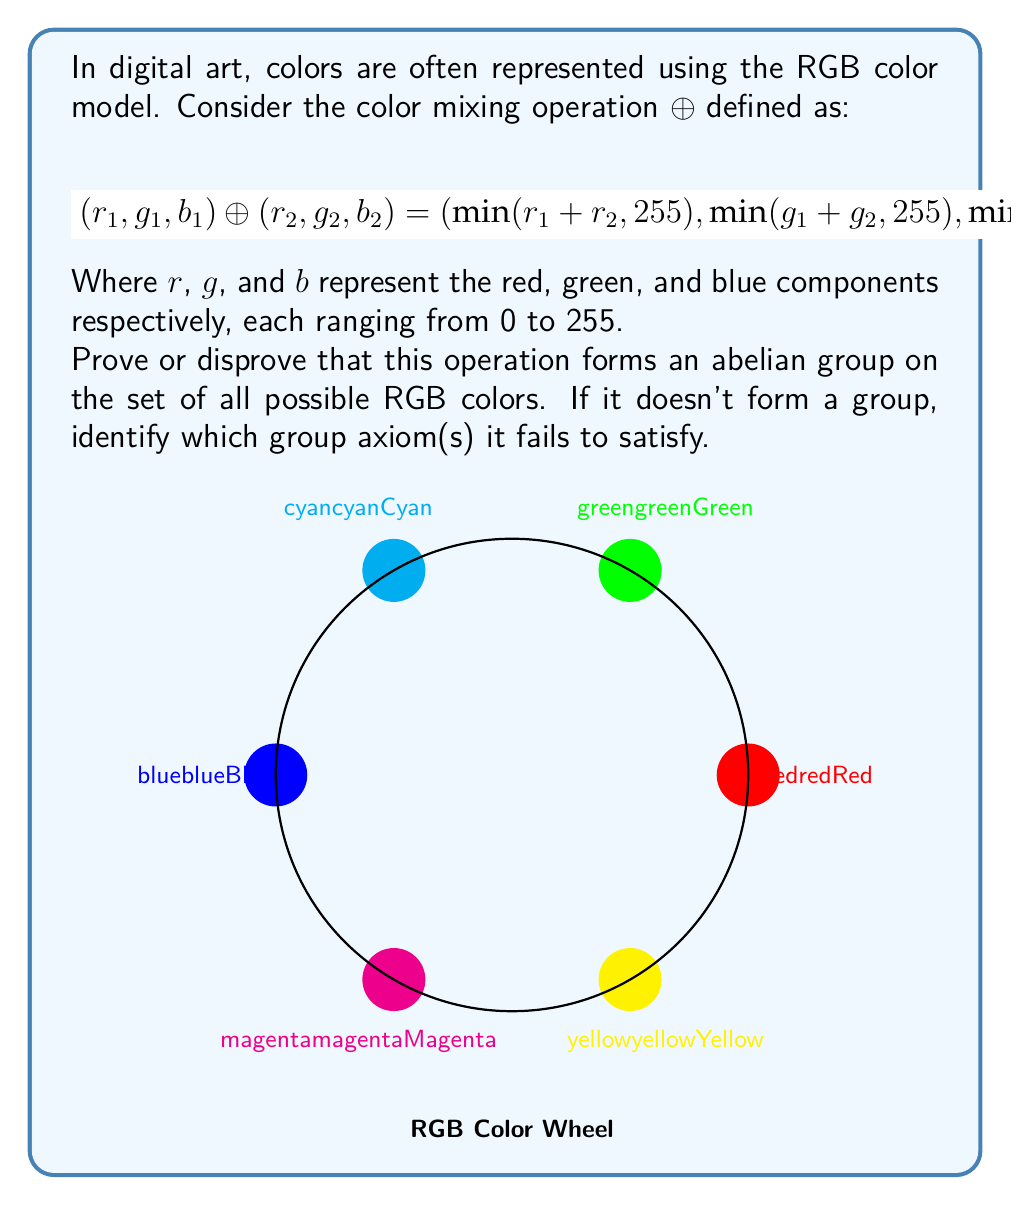Teach me how to tackle this problem. Let's analyze this operation with respect to the group axioms:

1. Closure: The operation ⊕ is closed on the set of RGB colors, as the result is always a valid RGB color due to the $\min$ function ensuring values stay within [0, 255].

2. Associativity: The operation is associative. For any RGB colors $a$, $b$, and $c$:
   $$(a ⊕ b) ⊕ c = a ⊕ (b ⊕ c)$$
   This holds because addition is associative and the $\min$ function is applied component-wise.

3. Identity element: The identity element exists and it's (0, 0, 0) (black). For any RGB color $(r, g, b)$:
   $$(r, g, b) ⊕ (0, 0, 0) = (r, g, b)$$

4. Inverse elements: This is where the operation fails to form a group. Not every element has an inverse. For example, there's no RGB color that, when combined with (255, 0, 0) (pure red), results in (0, 0, 0) (black).

5. Commutativity: The operation is commutative. For any RGB colors $a$ and $b$:
   $$a ⊕ b = b ⊕ a$$
   This holds because addition and the $\min$ function are both commutative.

Therefore, this color mixing operation does not form an abelian group on the set of all possible RGB colors. It satisfies closure, associativity, identity, and commutativity, but fails to provide inverse elements for all colors.

This algebraic structure is actually a commutative monoid, which is similar to a group but doesn't require the existence of inverse elements.
Answer: Not a group; lacks inverse elements 